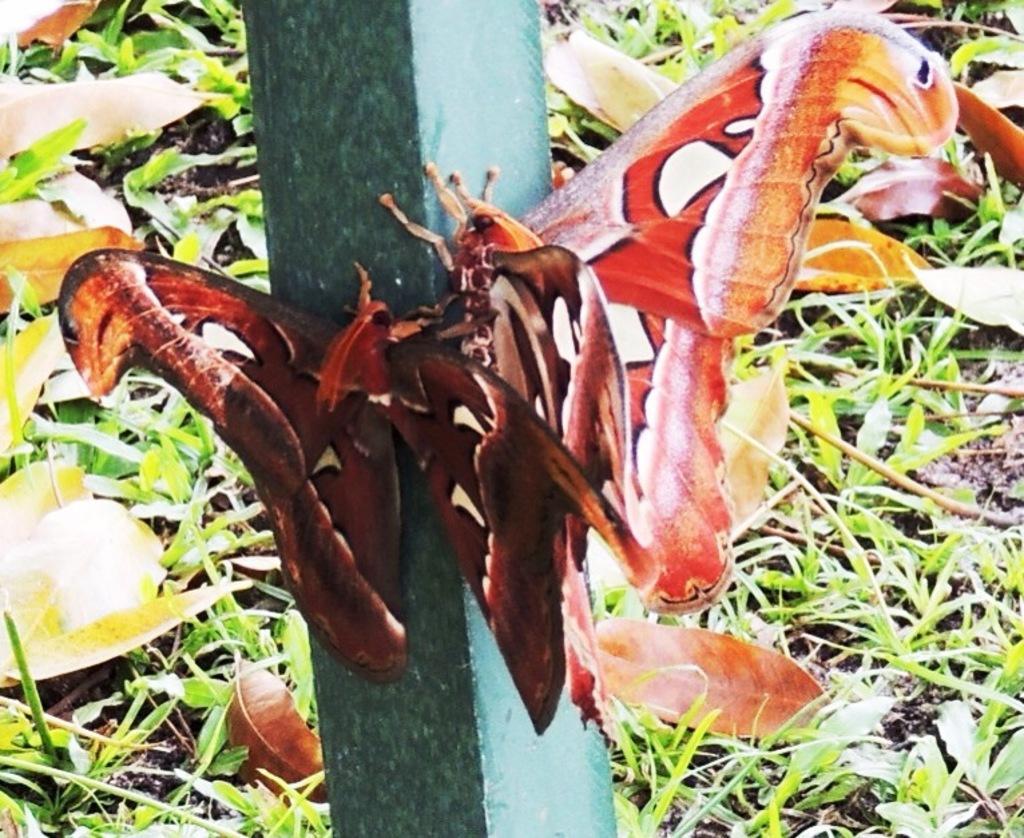Please provide a concise description of this image. This image is taken outdoors. In the background there is a ground with grass and a few dry leaves on it. In the middle of the image there is a pole and there are two butterflies on the pole. 